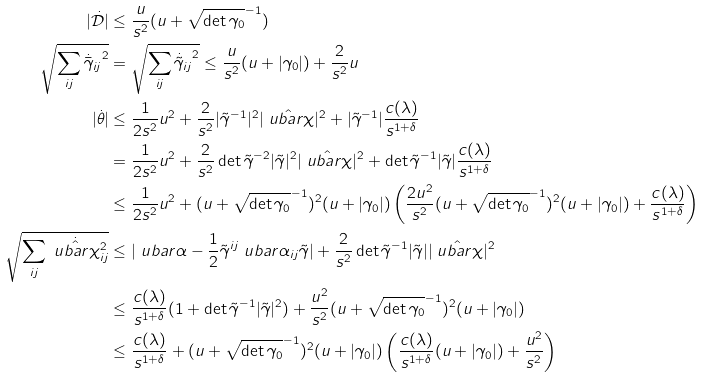Convert formula to latex. <formula><loc_0><loc_0><loc_500><loc_500>| \dot { \mathcal { D } } | & \leq \frac { u } { s ^ { 2 } } ( u + \sqrt { \det \gamma _ { 0 } } ^ { - 1 } ) \\ \sqrt { \sum _ { i j } { \dot { \bar { \gamma } } _ { i j } } ^ { 2 } } & = \sqrt { \sum _ { i j } { { \dot { \tilde { \gamma } } _ { i j } } } ^ { 2 } } \leq \frac { u } { s ^ { 2 } } ( u + | \gamma _ { 0 } | ) + \frac { 2 } { s ^ { 2 } } u \\ | \dot { \theta } | & \leq \frac { 1 } { 2 s ^ { 2 } } u ^ { 2 } + \frac { 2 } { s ^ { 2 } } | \tilde { \gamma } ^ { - 1 } | ^ { 2 } | \hat { \ u b a r \chi } | ^ { 2 } + | \tilde { \gamma } ^ { - 1 } | \frac { c ( \lambda ) } { s ^ { 1 + \delta } } \\ & = \frac { 1 } { 2 s ^ { 2 } } u ^ { 2 } + \frac { 2 } { s ^ { 2 } } \det \tilde { \gamma } ^ { - 2 } | \tilde { \gamma } | ^ { 2 } | \hat { \ u b a r \chi } | ^ { 2 } + \det \tilde { \gamma } ^ { - 1 } | \tilde { \gamma } | \frac { c ( \lambda ) } { s ^ { 1 + \delta } } \\ & \leq \frac { 1 } { 2 s ^ { 2 } } u ^ { 2 } + ( u + \sqrt { \det \gamma _ { 0 } } ^ { - 1 } ) ^ { 2 } ( u + | \gamma _ { 0 } | ) \left ( \frac { 2 u ^ { 2 } } { s ^ { 2 } } ( u + \sqrt { \det \gamma _ { 0 } } ^ { - 1 } ) ^ { 2 } ( u + | \gamma _ { 0 } | ) + \frac { c ( \lambda ) } { s ^ { 1 + \delta } } \right ) \\ \sqrt { \sum _ { i j } { \dot { \hat { \ u b a r \chi } } ^ { 2 } _ { i j } } } & \leq | \ u b a r \alpha - \frac { 1 } { 2 } \tilde { \gamma } ^ { i j } \ u b a r \alpha _ { i j } \tilde { \gamma } | + \frac { 2 } { s ^ { 2 } } \det \tilde { \gamma } ^ { - 1 } | \tilde { \gamma } | | \hat { \ u b a r \chi } | ^ { 2 } \\ & \leq \frac { c ( \lambda ) } { s ^ { 1 + \delta } } ( 1 + \det \tilde { \gamma } ^ { - 1 } | \tilde { \gamma } | ^ { 2 } ) + \frac { u ^ { 2 } } { s ^ { 2 } } ( u + \sqrt { \det \gamma _ { 0 } } ^ { - 1 } ) ^ { 2 } ( u + | \gamma _ { 0 } | ) \\ & \leq \frac { c ( \lambda ) } { s ^ { 1 + \delta } } + ( u + \sqrt { \det \gamma _ { 0 } } ^ { - 1 } ) ^ { 2 } ( u + | \gamma _ { 0 } | ) \left ( \frac { c ( \lambda ) } { s ^ { 1 + \delta } } ( u + | \gamma _ { 0 } | ) + \frac { u ^ { 2 } } { s ^ { 2 } } \right )</formula> 